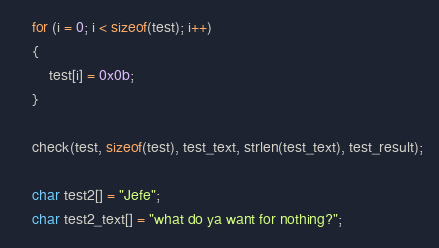Convert code to text. <code><loc_0><loc_0><loc_500><loc_500><_C_>	for (i = 0; i < sizeof(test); i++)
	{
		test[i] = 0x0b;
	}

	check(test, sizeof(test), test_text, strlen(test_text), test_result);

	char test2[] = "Jefe";
	char test2_text[] = "what do ya want for nothing?";</code> 